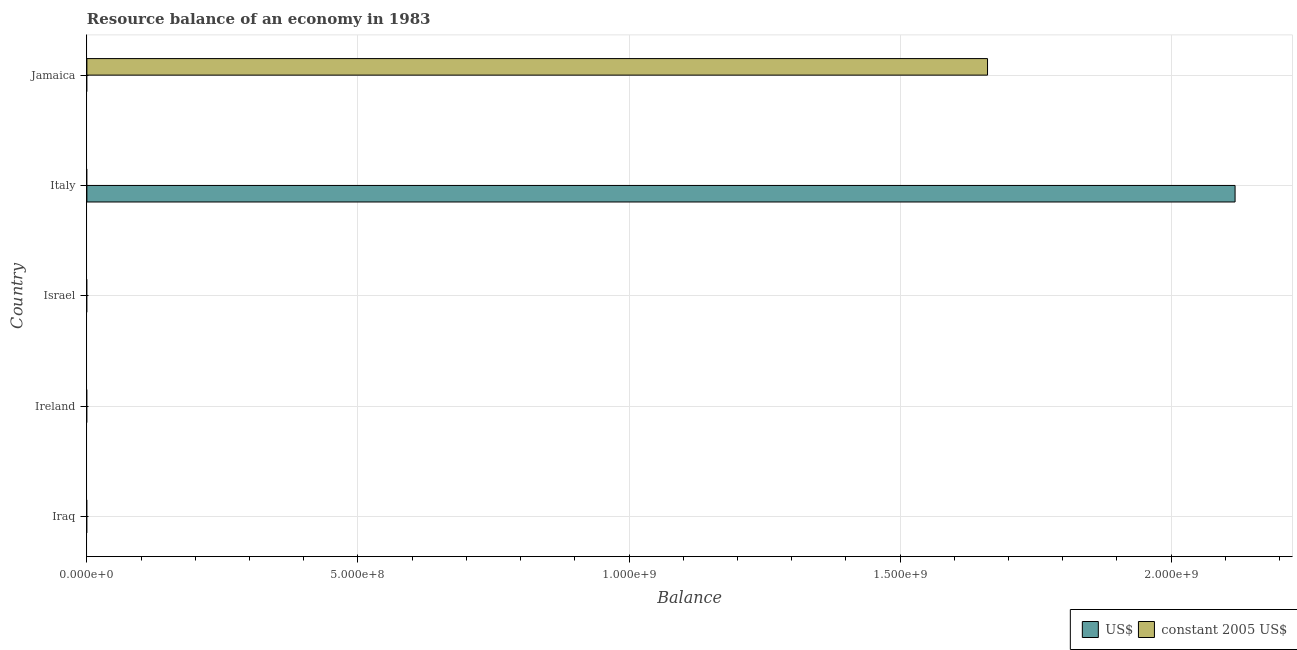Are the number of bars on each tick of the Y-axis equal?
Make the answer very short. No. How many bars are there on the 2nd tick from the top?
Your response must be concise. 1. How many bars are there on the 3rd tick from the bottom?
Offer a very short reply. 0. What is the label of the 5th group of bars from the top?
Provide a succinct answer. Iraq. What is the resource balance in constant us$ in Israel?
Offer a very short reply. 0. Across all countries, what is the maximum resource balance in us$?
Provide a succinct answer. 2.12e+09. In which country was the resource balance in constant us$ maximum?
Your response must be concise. Jamaica. What is the total resource balance in us$ in the graph?
Ensure brevity in your answer.  2.12e+09. What is the difference between the resource balance in constant us$ in Iraq and the resource balance in us$ in Italy?
Provide a succinct answer. -2.12e+09. What is the average resource balance in us$ per country?
Offer a very short reply. 4.24e+08. What is the difference between the highest and the lowest resource balance in us$?
Make the answer very short. 2.12e+09. In how many countries, is the resource balance in constant us$ greater than the average resource balance in constant us$ taken over all countries?
Offer a terse response. 1. Are all the bars in the graph horizontal?
Provide a succinct answer. Yes. How many countries are there in the graph?
Your answer should be very brief. 5. How many legend labels are there?
Offer a terse response. 2. How are the legend labels stacked?
Your answer should be very brief. Horizontal. What is the title of the graph?
Your answer should be compact. Resource balance of an economy in 1983. What is the label or title of the X-axis?
Make the answer very short. Balance. What is the Balance in US$ in Italy?
Offer a very short reply. 2.12e+09. What is the Balance of constant 2005 US$ in Italy?
Keep it short and to the point. 0. What is the Balance of constant 2005 US$ in Jamaica?
Your answer should be very brief. 1.66e+09. Across all countries, what is the maximum Balance of US$?
Your response must be concise. 2.12e+09. Across all countries, what is the maximum Balance in constant 2005 US$?
Give a very brief answer. 1.66e+09. Across all countries, what is the minimum Balance in US$?
Keep it short and to the point. 0. Across all countries, what is the minimum Balance of constant 2005 US$?
Provide a succinct answer. 0. What is the total Balance in US$ in the graph?
Your answer should be compact. 2.12e+09. What is the total Balance in constant 2005 US$ in the graph?
Your answer should be very brief. 1.66e+09. What is the difference between the Balance in US$ in Italy and the Balance in constant 2005 US$ in Jamaica?
Give a very brief answer. 4.57e+08. What is the average Balance in US$ per country?
Provide a short and direct response. 4.24e+08. What is the average Balance of constant 2005 US$ per country?
Give a very brief answer. 3.32e+08. What is the difference between the highest and the lowest Balance in US$?
Your response must be concise. 2.12e+09. What is the difference between the highest and the lowest Balance in constant 2005 US$?
Your answer should be very brief. 1.66e+09. 